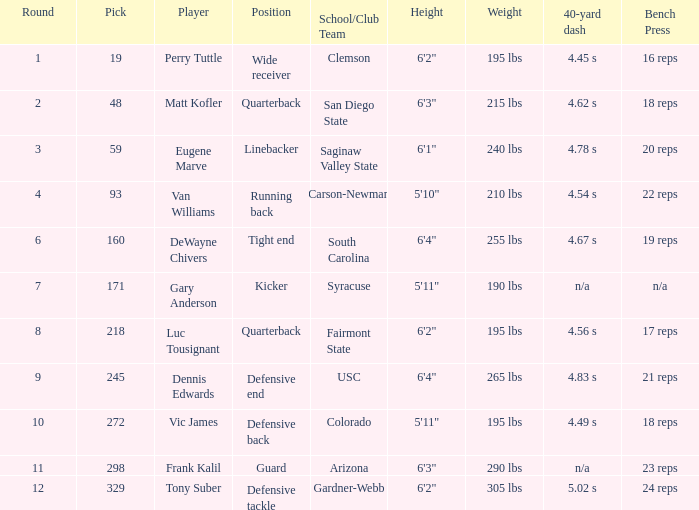Who plays linebacker? Eugene Marve. 